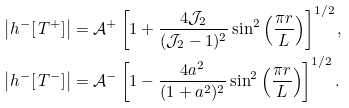<formula> <loc_0><loc_0><loc_500><loc_500>\left | h ^ { - } [ \, T ^ { + } ] \right | & = \mathcal { A } ^ { + } \left [ 1 + \frac { 4 \mathcal { J } _ { 2 } } { ( \mathcal { J } _ { 2 } - 1 ) ^ { 2 } } \sin ^ { 2 } \left ( \frac { \pi r } { L } \right ) \right ] ^ { 1 / 2 } , \\ \left | h ^ { - } [ \, T ^ { - } ] \right | & = \mathcal { A } ^ { - } \left [ 1 - \frac { 4 a ^ { 2 } } { ( 1 + a ^ { 2 } ) ^ { 2 } } \sin ^ { 2 } \left ( \frac { \pi r } { L } \right ) \right ] ^ { 1 / 2 } .</formula> 